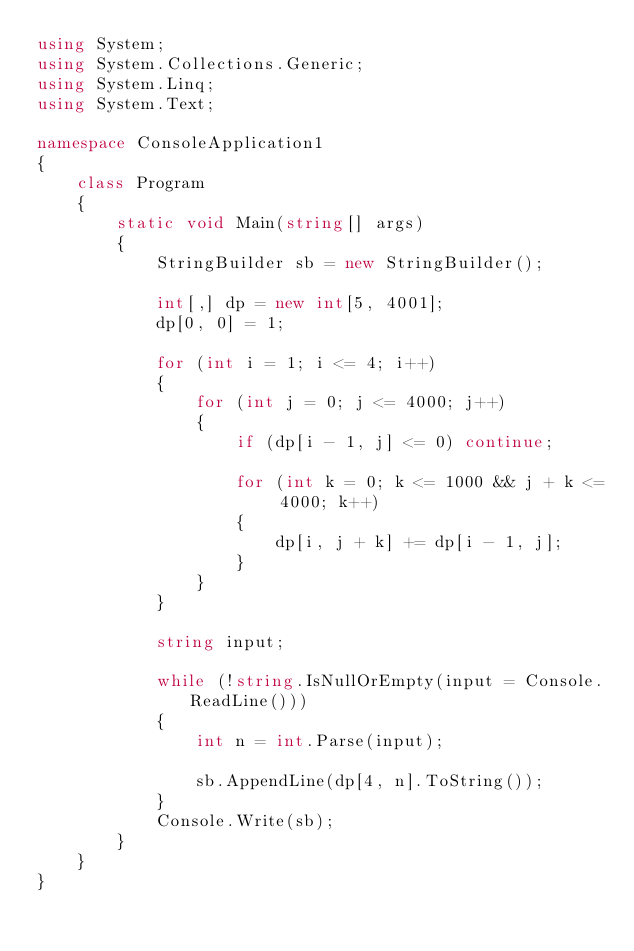<code> <loc_0><loc_0><loc_500><loc_500><_C#_>using System;
using System.Collections.Generic;
using System.Linq;
using System.Text;

namespace ConsoleApplication1
{
    class Program
    {
        static void Main(string[] args)
        {
            StringBuilder sb = new StringBuilder();

            int[,] dp = new int[5, 4001];
            dp[0, 0] = 1;

            for (int i = 1; i <= 4; i++)
            {
                for (int j = 0; j <= 4000; j++)
                {
                    if (dp[i - 1, j] <= 0) continue;

                    for (int k = 0; k <= 1000 && j + k <= 4000; k++)
                    {
                        dp[i, j + k] += dp[i - 1, j];
                    }
                }
            }

            string input;

            while (!string.IsNullOrEmpty(input = Console.ReadLine()))
            {
                int n = int.Parse(input);

                sb.AppendLine(dp[4, n].ToString());
            }
            Console.Write(sb);
        }
    }
}</code> 